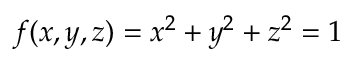<formula> <loc_0><loc_0><loc_500><loc_500>f ( x , y , z ) = x ^ { 2 } + y ^ { 2 } + z ^ { 2 } = 1</formula> 